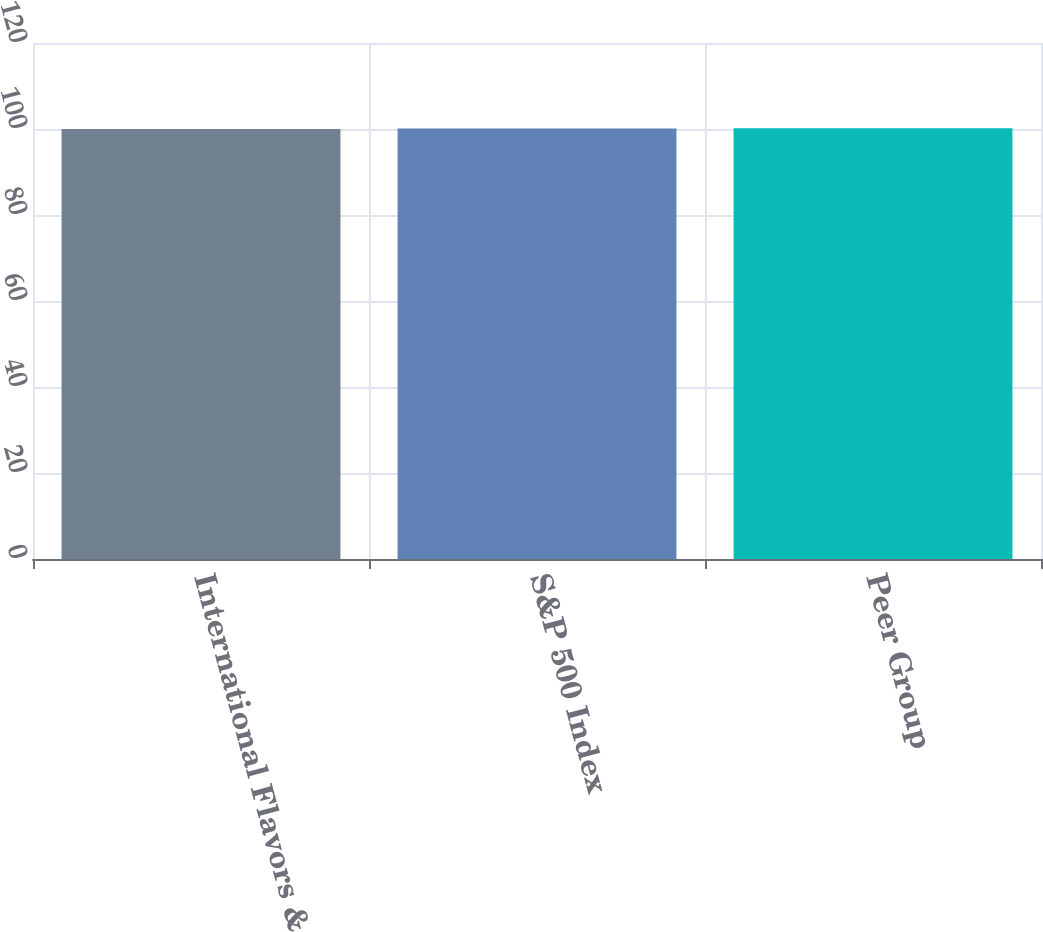Convert chart. <chart><loc_0><loc_0><loc_500><loc_500><bar_chart><fcel>International Flavors &<fcel>S&P 500 Index<fcel>Peer Group<nl><fcel>100<fcel>100.1<fcel>100.2<nl></chart> 